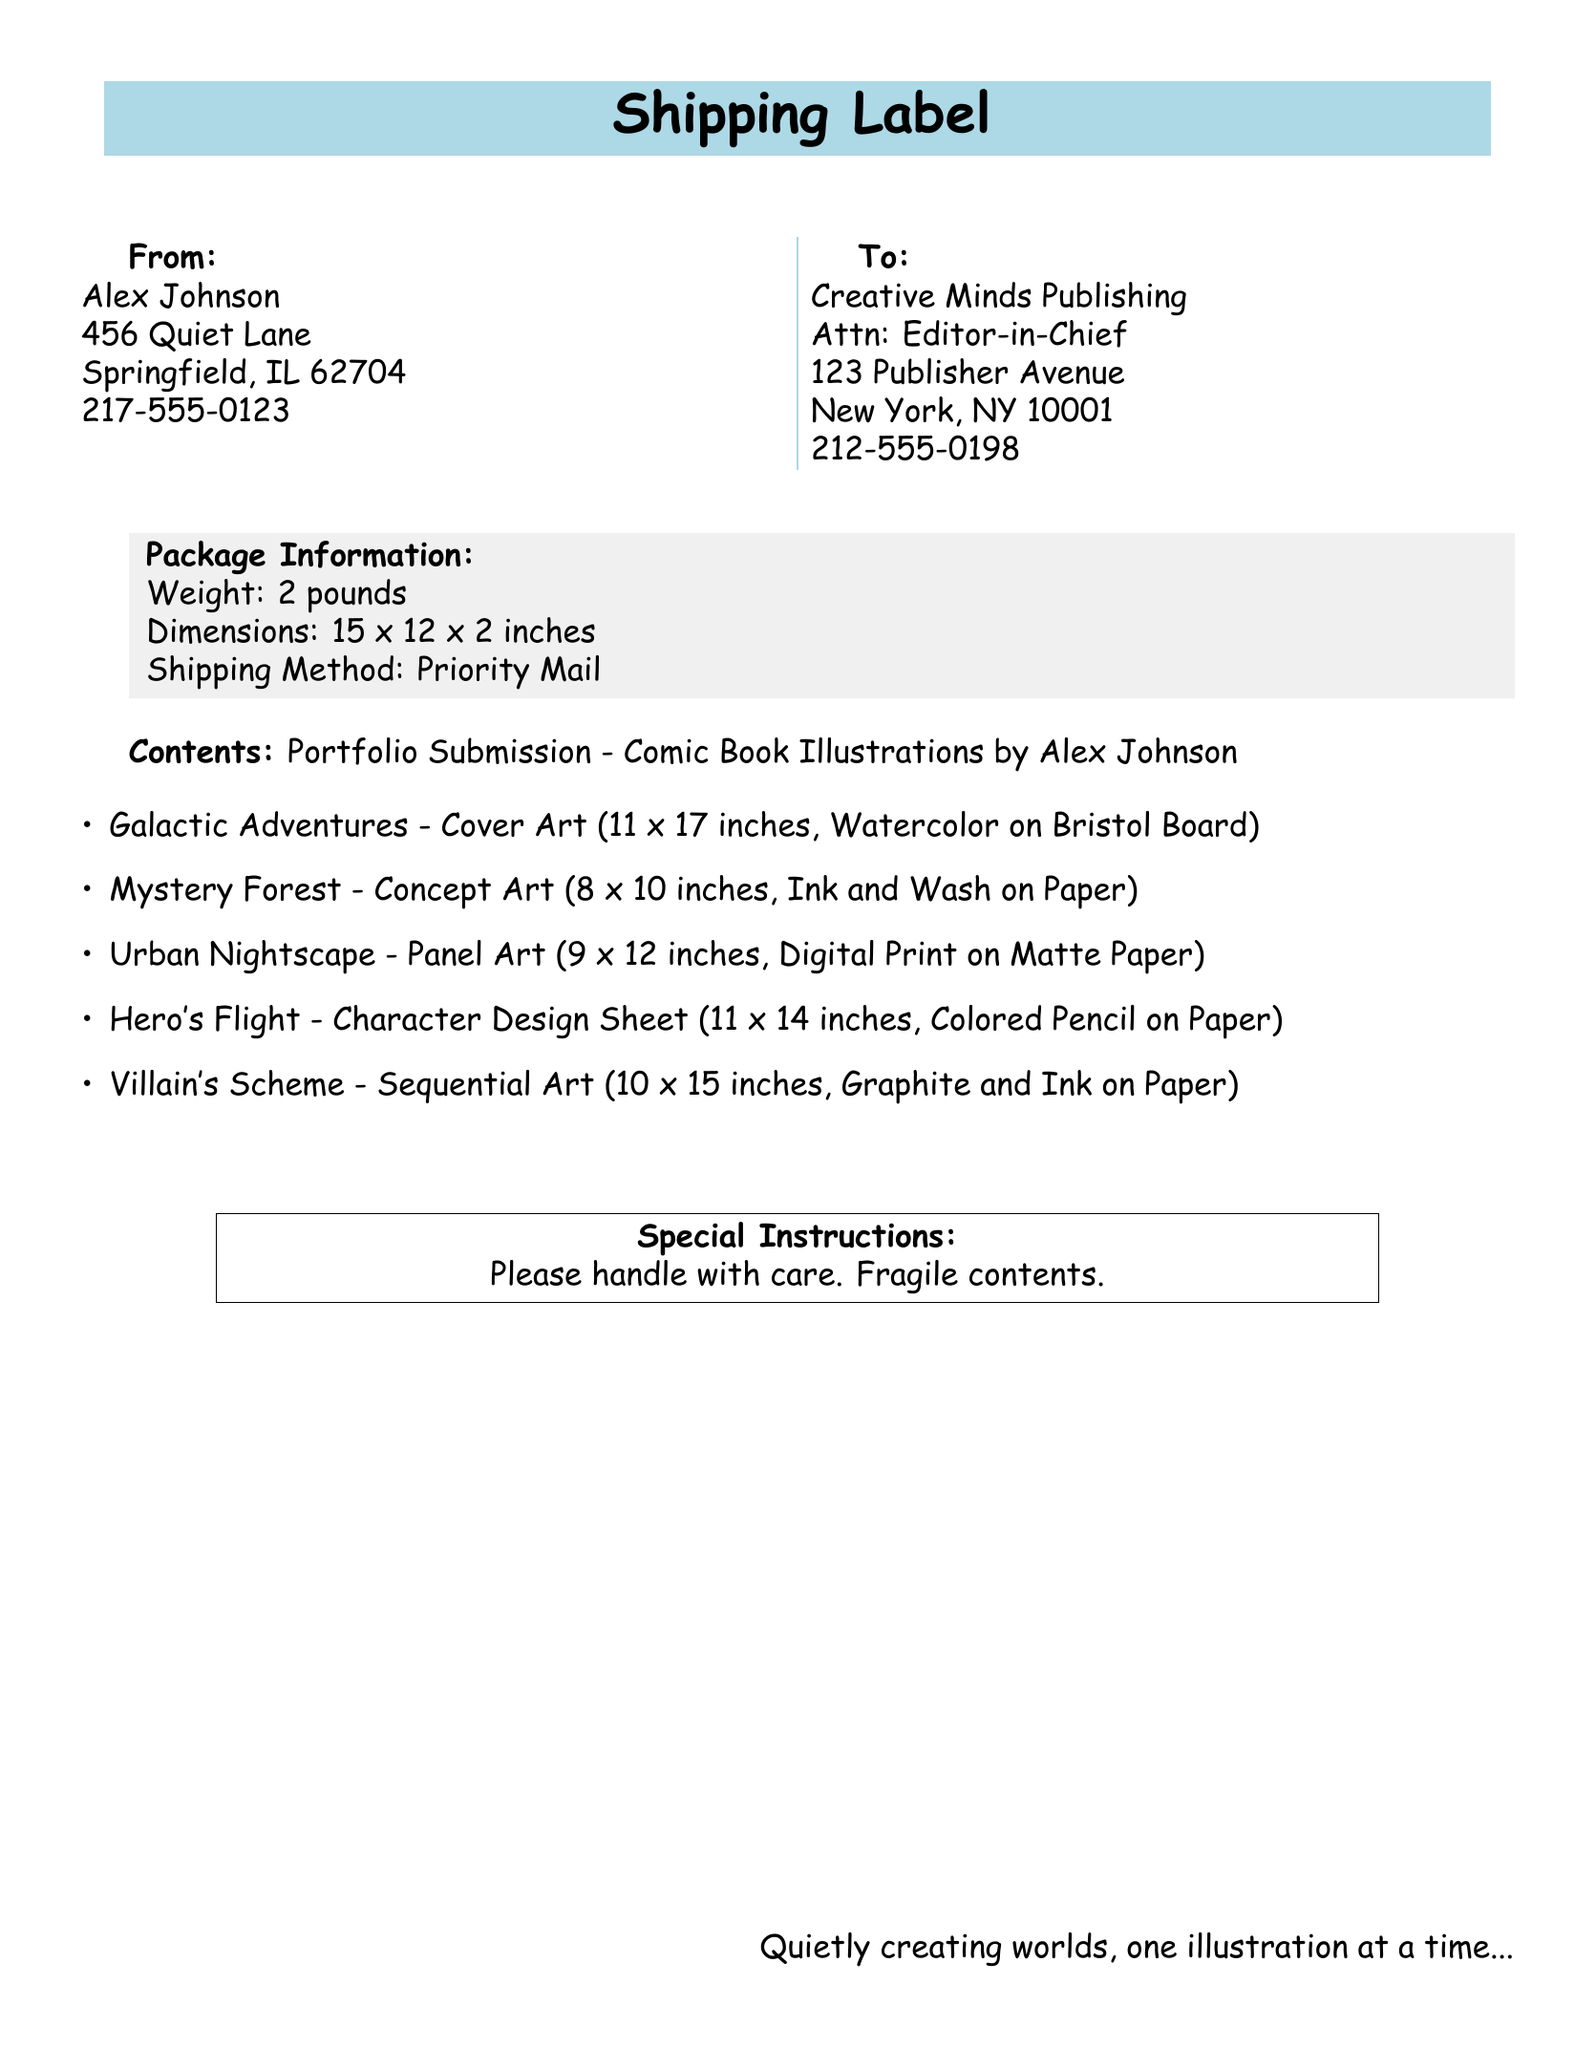What is the sender's name? The sender's name is listed at the top of the document in the "From" section.
Answer: Alex Johnson What is the recipient's address? The address of the recipient is provided in the "To" section of the document.
Answer: 123 Publisher Avenue, New York, NY 10001 What is the weight of the package? The weight of the package is noted in the "Package Information" section.
Answer: 2 pounds What is the dimension of the cover art illustration? The dimensions of the illustrations are mentioned in the list of contents.
Answer: 11 x 17 inches How many illustrations are listed in the document? The total number of illustrations can be counted from the list provided.
Answer: 5 What shipping method is used? The shipping method is specified in the "Package Information" section.
Answer: Priority Mail What is the special instruction for the package? The special instructions are clearly outlined in a designated box at the bottom of the document.
Answer: Please handle with care. Fragile contents What type of art is "Hero's Flight"? The type of art is included within the details of the illustrations provided.
Answer: Character Design Sheet What medium is used for "Mystery Forest"? The medium is mentioned with each illustration in the list of contents.
Answer: Ink and Wash on Paper 